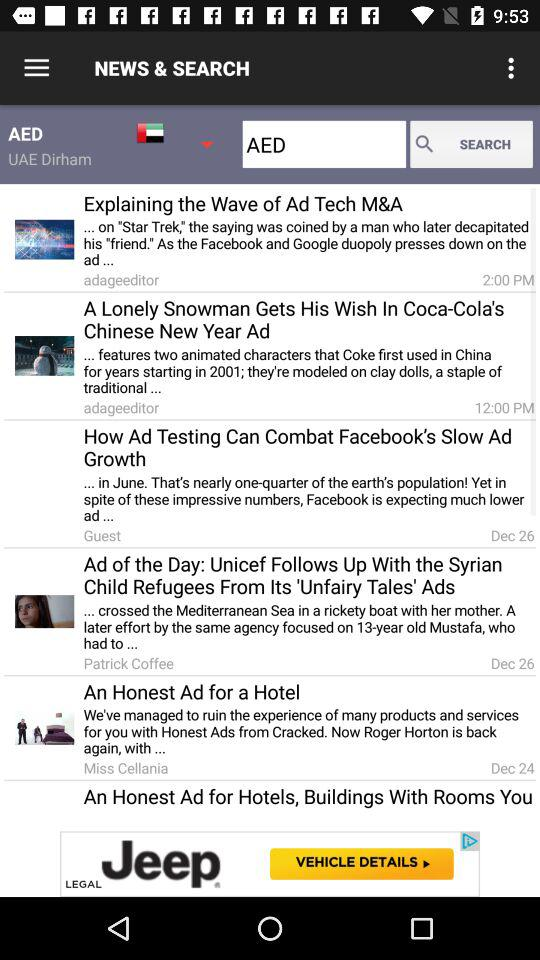Who's the author of the article "An Honest Ad for a Hotel"? The author is MIss Cellania. 